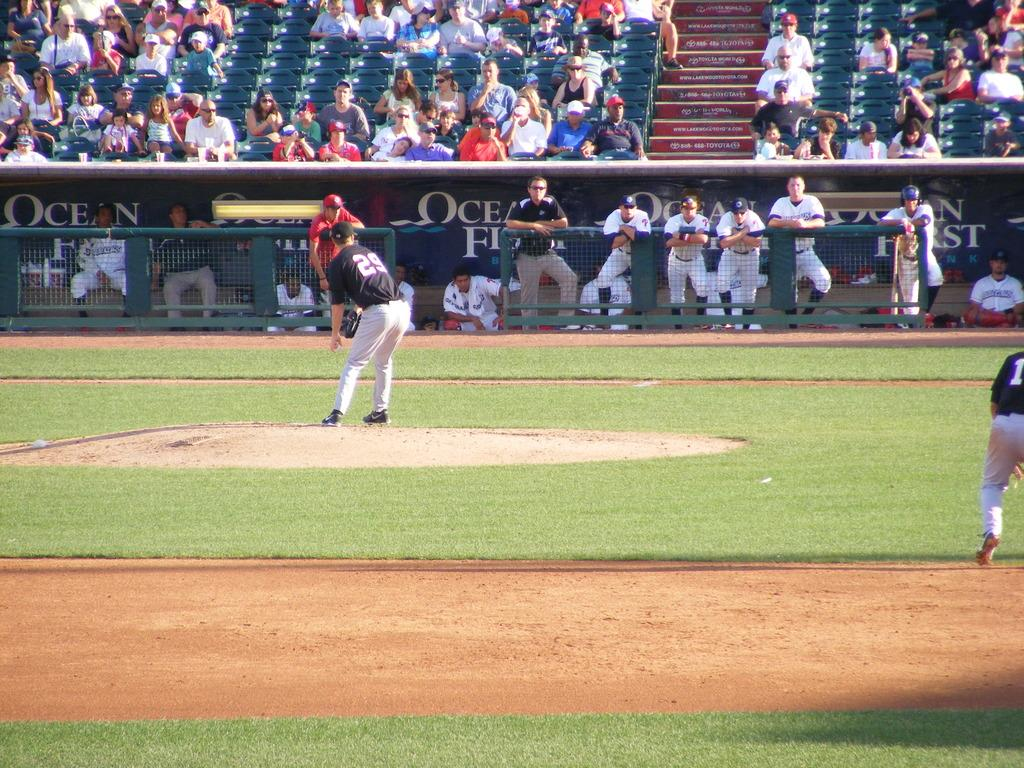<image>
Create a compact narrative representing the image presented. A pitcher at a baseball game with the number 29 on his back. 